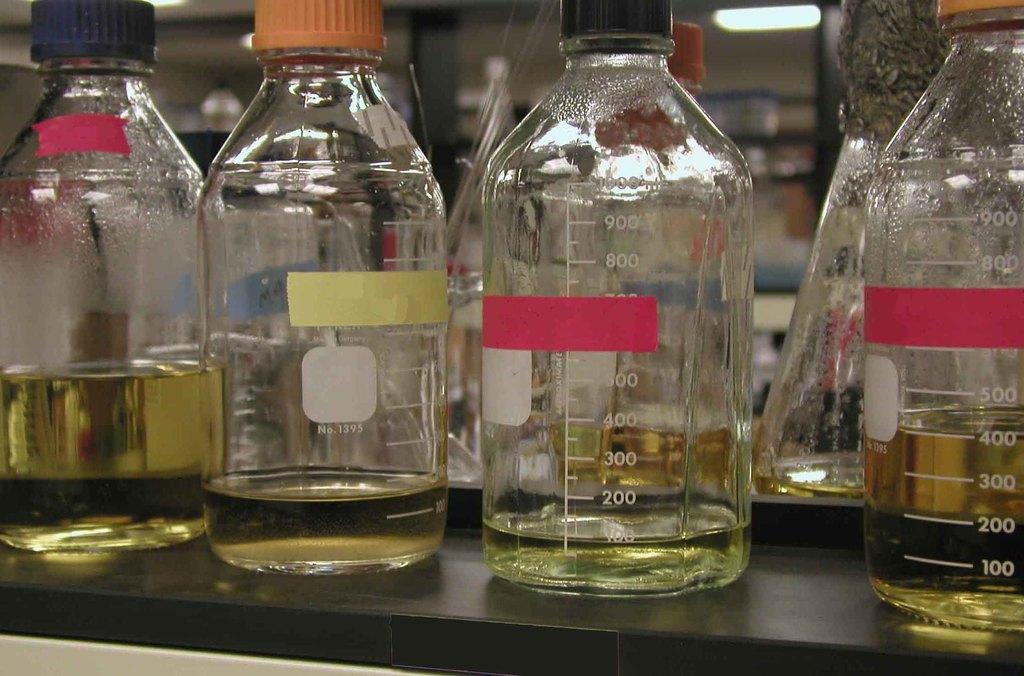Could you give a brief overview of what you see in this image? This image consists of bottles and there is some liquid in that bottles. There are stickers placed on that bottles. 